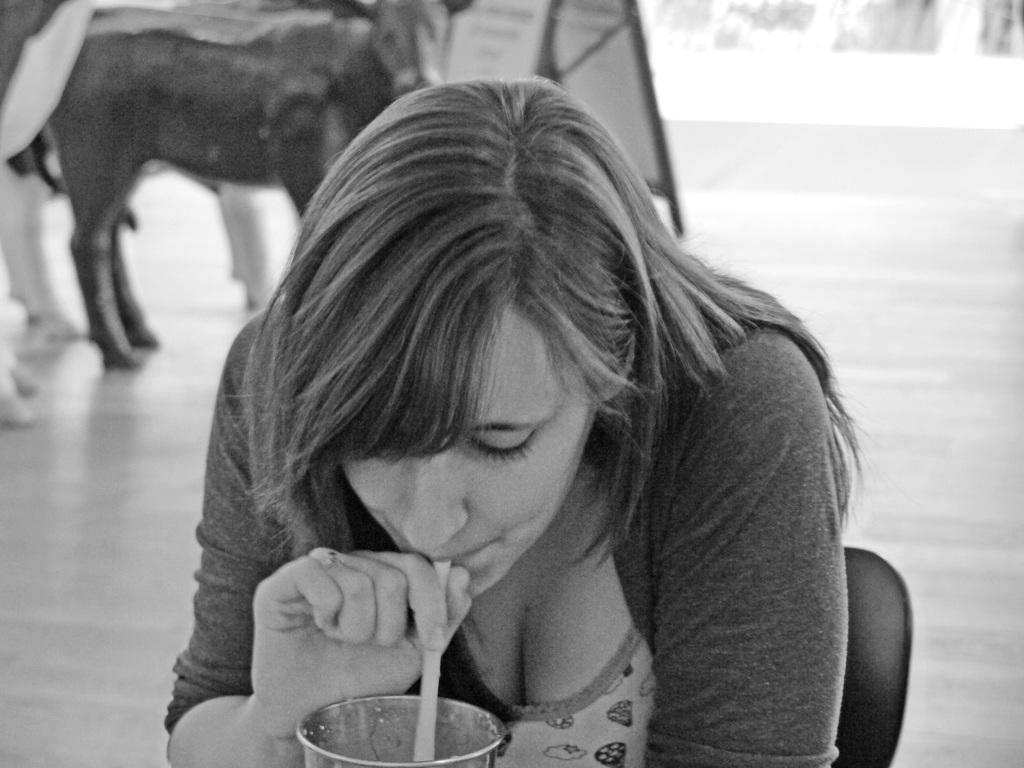Could you give a brief overview of what you see in this image? In the foreground area of this image there is a lady who is siting in the center of the image, by holding a straw in her hand, which is in the glass and there is a calf and a board in the background area. 